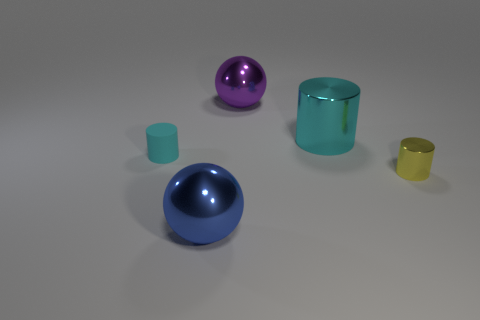Is there a big blue thing?
Your response must be concise. Yes. There is a large metallic sphere that is behind the small shiny object; is there a cyan object that is left of it?
Ensure brevity in your answer.  Yes. There is a big cyan object that is the same shape as the tiny metallic thing; what is it made of?
Give a very brief answer. Metal. Are there more small cylinders than cylinders?
Provide a short and direct response. No. There is a tiny matte cylinder; is its color the same as the cylinder behind the rubber thing?
Offer a terse response. Yes. What is the color of the big metallic object that is behind the tiny yellow metal thing and to the left of the big cyan metallic cylinder?
Provide a succinct answer. Purple. How many other things are made of the same material as the blue thing?
Ensure brevity in your answer.  3. Is the number of small yellow things less than the number of blue matte objects?
Offer a very short reply. No. Is the material of the small yellow thing the same as the cyan cylinder left of the cyan shiny cylinder?
Give a very brief answer. No. What is the shape of the cyan object left of the big purple object?
Make the answer very short. Cylinder. 